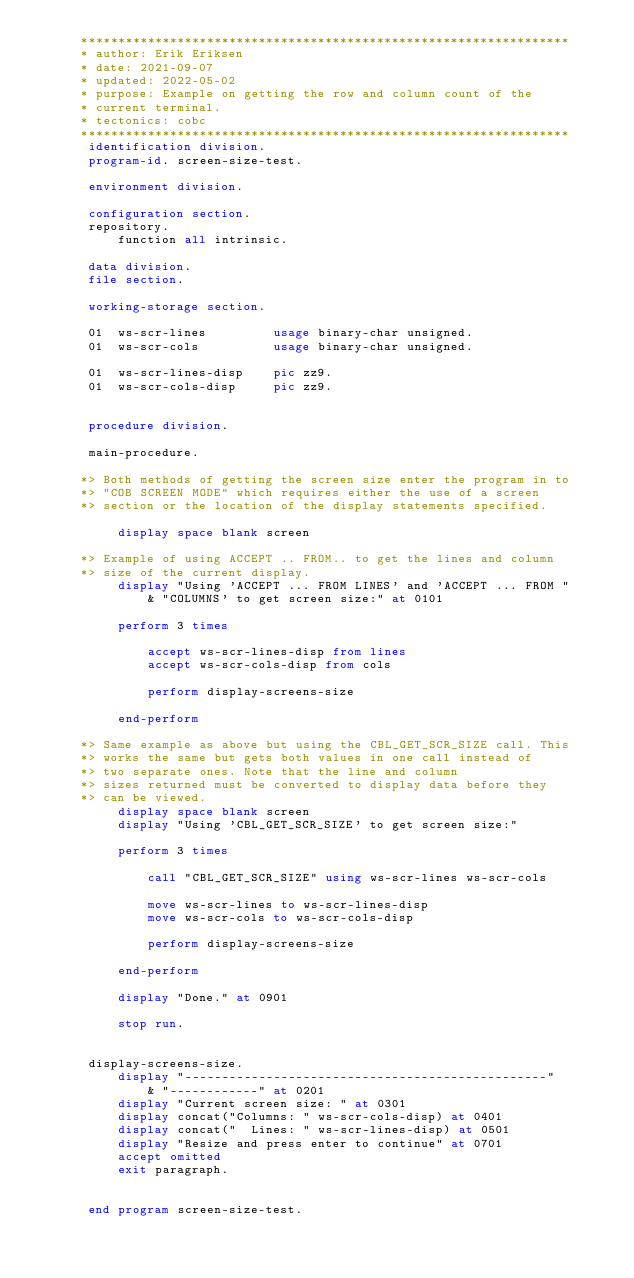Convert code to text. <code><loc_0><loc_0><loc_500><loc_500><_COBOL_>      ******************************************************************
      * author: Erik Eriksen
      * date: 2021-09-07
      * updated: 2022-05-02
      * purpose: Example on getting the row and column count of the
      * current terminal.
      * tectonics: cobc
      ******************************************************************
       identification division.
       program-id. screen-size-test.

       environment division.

       configuration section.
       repository.
           function all intrinsic.

       data division.
       file section.

       working-storage section.

       01  ws-scr-lines         usage binary-char unsigned.
       01  ws-scr-cols          usage binary-char unsigned.

       01  ws-scr-lines-disp    pic zz9.
       01  ws-scr-cols-disp     pic zz9.


       procedure division.

       main-procedure.

      *> Both methods of getting the screen size enter the program in to
      *> "COB SCREEN MODE" which requires either the use of a screen
      *> section or the location of the display statements specified.

           display space blank screen

      *> Example of using ACCEPT .. FROM.. to get the lines and column
      *> size of the current display.
           display "Using 'ACCEPT ... FROM LINES' and 'ACCEPT ... FROM "
               & "COLUMNS' to get screen size:" at 0101

           perform 3 times

               accept ws-scr-lines-disp from lines
               accept ws-scr-cols-disp from cols

               perform display-screens-size

           end-perform

      *> Same example as above but using the CBL_GET_SCR_SIZE call. This
      *> works the same but gets both values in one call instead of
      *> two separate ones. Note that the line and column
      *> sizes returned must be converted to display data before they
      *> can be viewed.
           display space blank screen
           display "Using 'CBL_GET_SCR_SIZE' to get screen size:"

           perform 3 times

               call "CBL_GET_SCR_SIZE" using ws-scr-lines ws-scr-cols

               move ws-scr-lines to ws-scr-lines-disp
               move ws-scr-cols to ws-scr-cols-disp

               perform display-screens-size

           end-perform

           display "Done." at 0901

           stop run.


       display-screens-size.
           display "-------------------------------------------------"
               & "------------" at 0201
           display "Current screen size: " at 0301
           display concat("Columns: " ws-scr-cols-disp) at 0401
           display concat("  Lines: " ws-scr-lines-disp) at 0501
           display "Resize and press enter to continue" at 0701
           accept omitted
           exit paragraph.


       end program screen-size-test.
</code> 